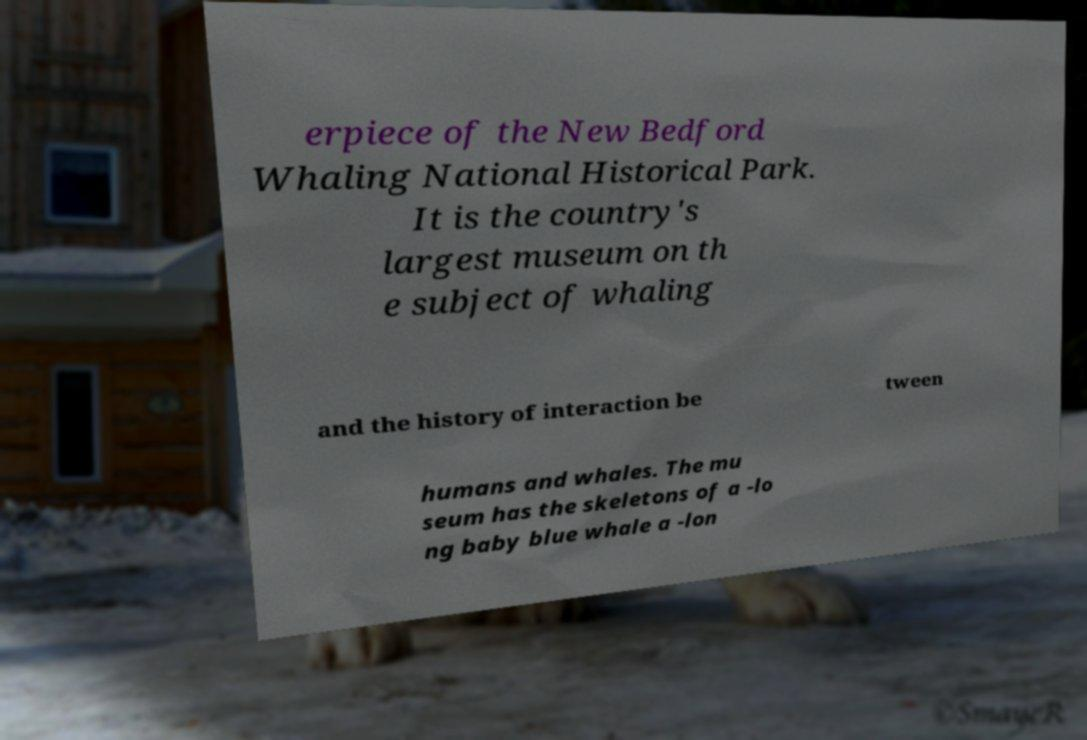I need the written content from this picture converted into text. Can you do that? erpiece of the New Bedford Whaling National Historical Park. It is the country's largest museum on th e subject of whaling and the history of interaction be tween humans and whales. The mu seum has the skeletons of a -lo ng baby blue whale a -lon 